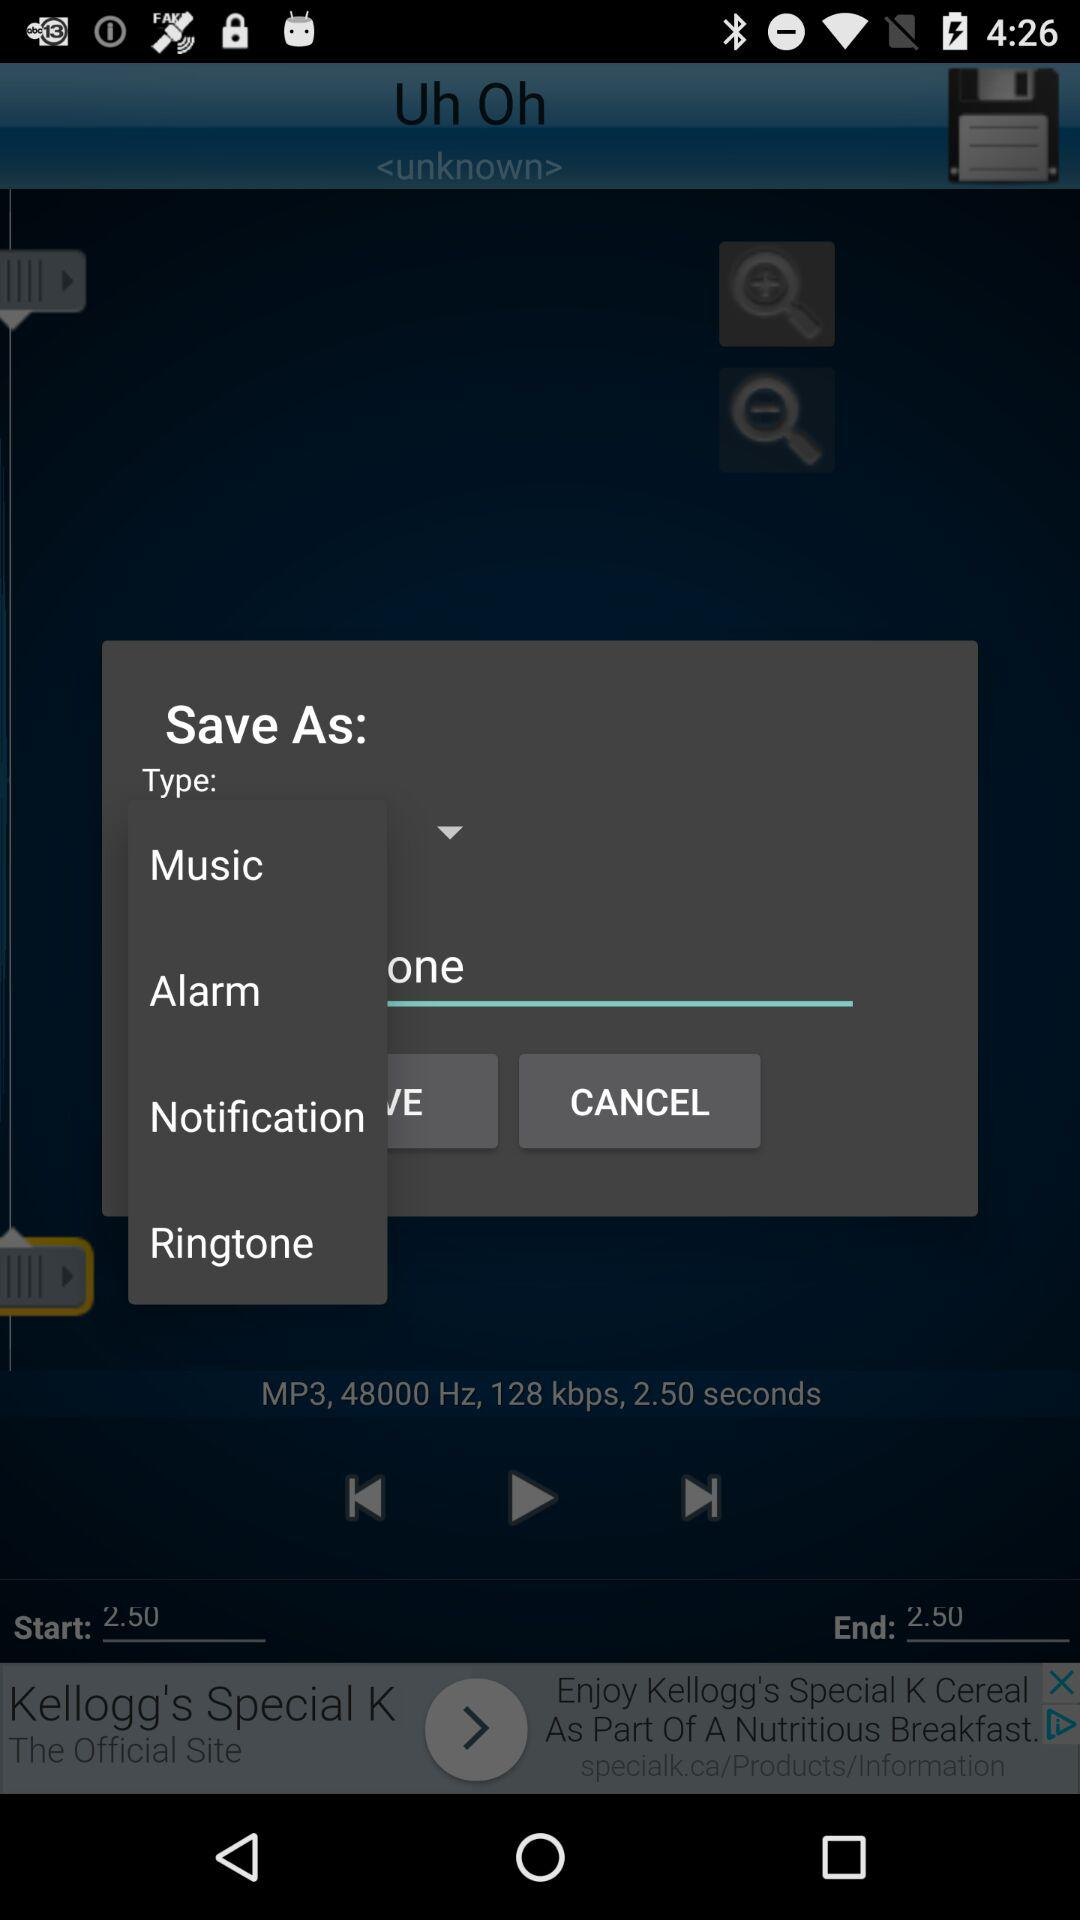What is the end time of the song?
When the provided information is insufficient, respond with <no answer>. <no answer> 